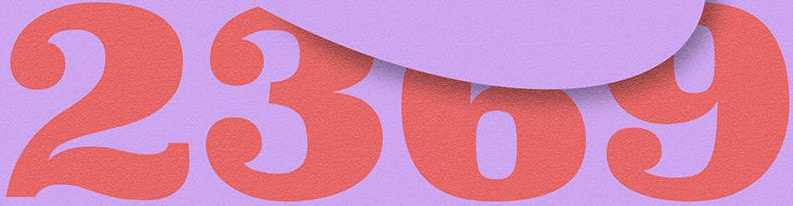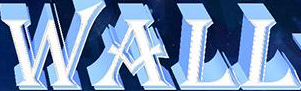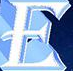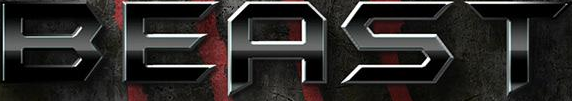Read the text content from these images in order, separated by a semicolon. 2369; WALL; E; BEAST 